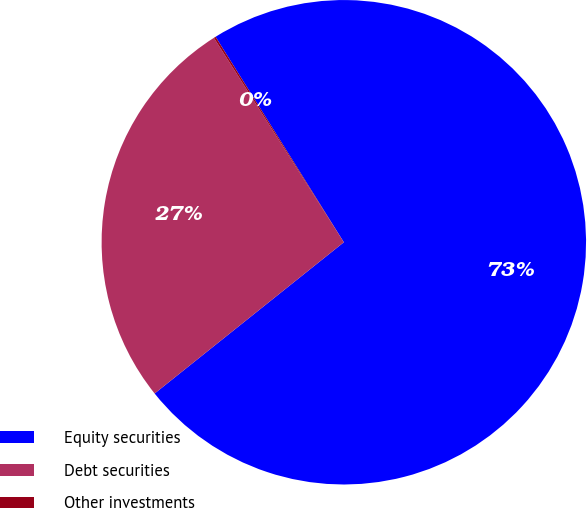<chart> <loc_0><loc_0><loc_500><loc_500><pie_chart><fcel>Equity securities<fcel>Debt securities<fcel>Other investments<nl><fcel>73.15%<fcel>26.72%<fcel>0.13%<nl></chart> 